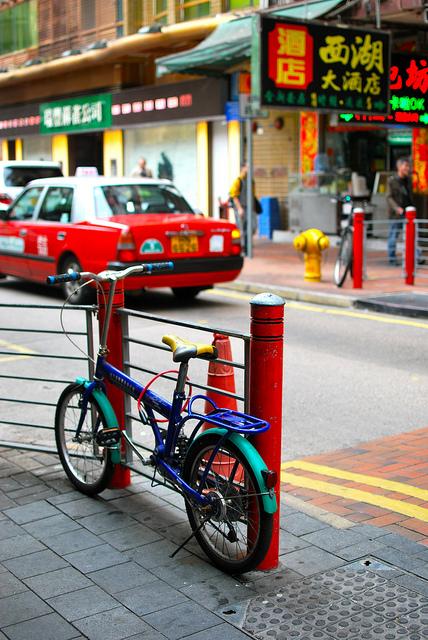Would the taxi need to move if there was a fire nearby?
Short answer required. Yes. What color is the taxi?
Give a very brief answer. Red. What are the colors on the parked bicycle?
Write a very short answer. Green and blue. How many yellow poles are there?
Be succinct. 0. 